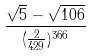Convert formula to latex. <formula><loc_0><loc_0><loc_500><loc_500>\frac { \sqrt { 5 } - \sqrt { 1 0 6 } } { ( \frac { 2 } { 4 2 9 } ) ^ { 3 6 6 } }</formula> 